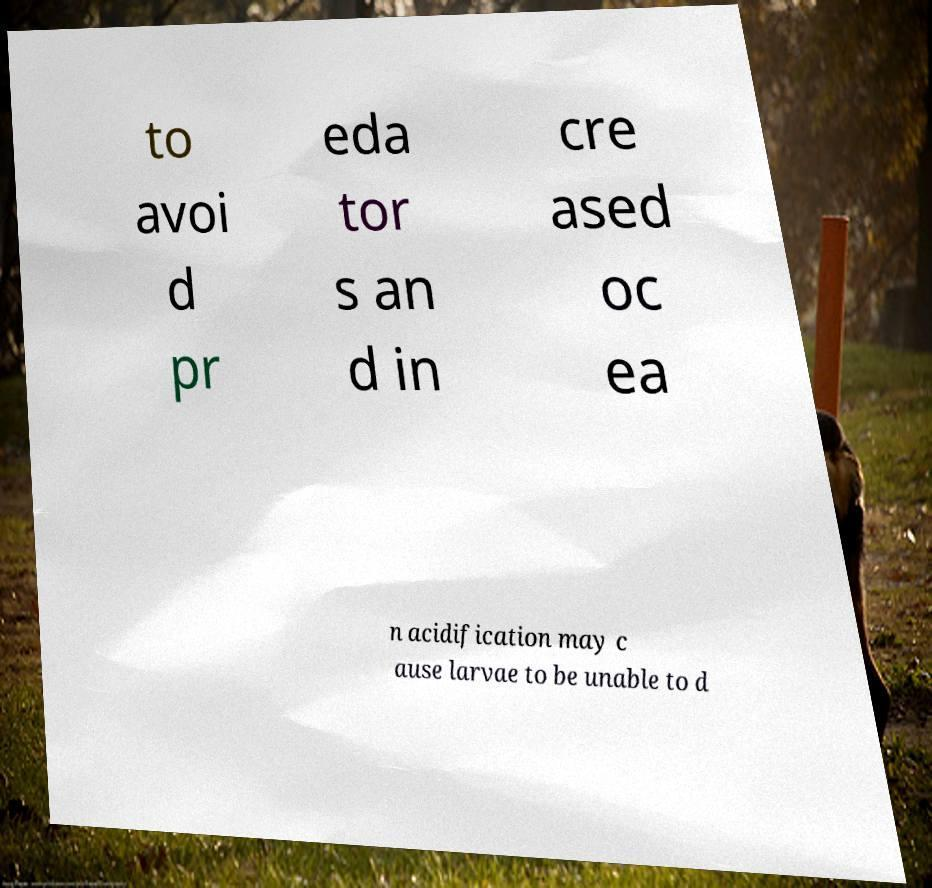Can you read and provide the text displayed in the image?This photo seems to have some interesting text. Can you extract and type it out for me? to avoi d pr eda tor s an d in cre ased oc ea n acidification may c ause larvae to be unable to d 